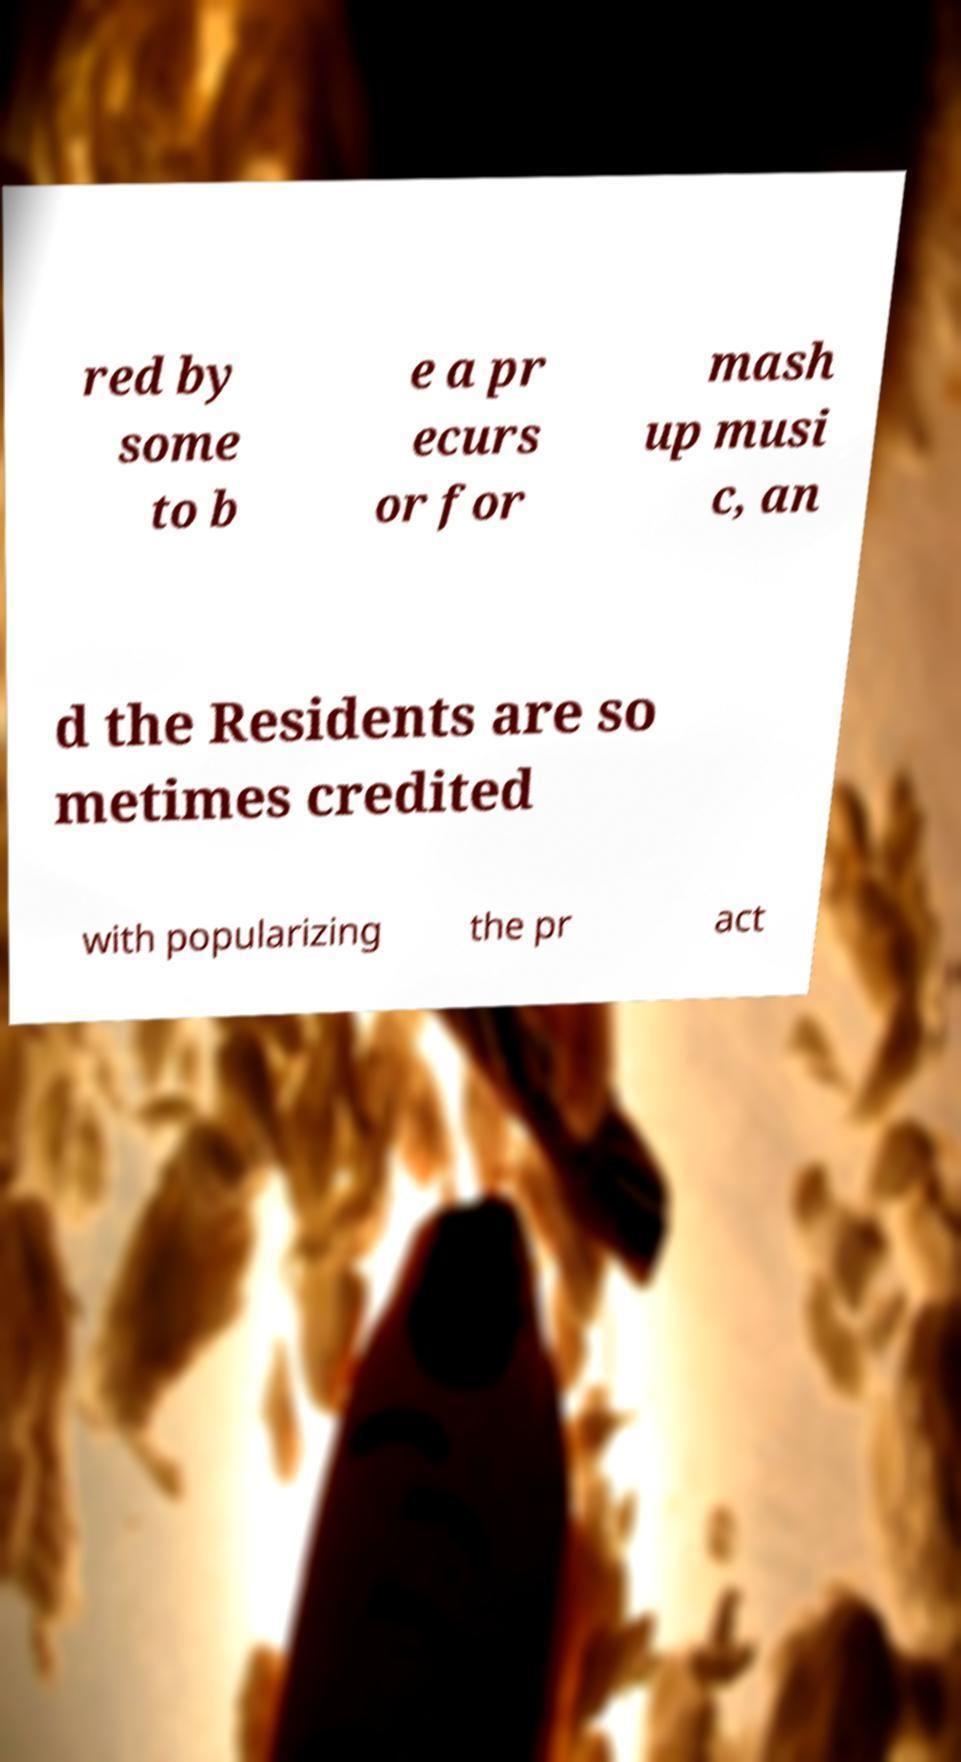There's text embedded in this image that I need extracted. Can you transcribe it verbatim? red by some to b e a pr ecurs or for mash up musi c, an d the Residents are so metimes credited with popularizing the pr act 